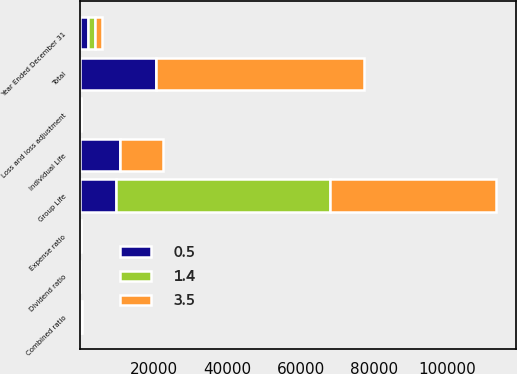Convert chart. <chart><loc_0><loc_0><loc_500><loc_500><stacked_bar_chart><ecel><fcel>Year Ended December 31<fcel>Loss and loss adjustment<fcel>Expense ratio<fcel>Dividend ratio<fcel>Combined ratio<fcel>Individual Life<fcel>Group Life<fcel>Total<nl><fcel>0.5<fcel>2005<fcel>89.4<fcel>31.2<fcel>0.3<fcel>120.9<fcel>10711<fcel>9838<fcel>20549<nl><fcel>3.5<fcel>2004<fcel>74.6<fcel>31.5<fcel>0.2<fcel>106.3<fcel>11566<fcel>45079<fcel>56645<nl><fcel>1.4<fcel>2003<fcel>111.8<fcel>37.3<fcel>1.4<fcel>150.5<fcel>135.7<fcel>58163<fcel>135.7<nl></chart> 